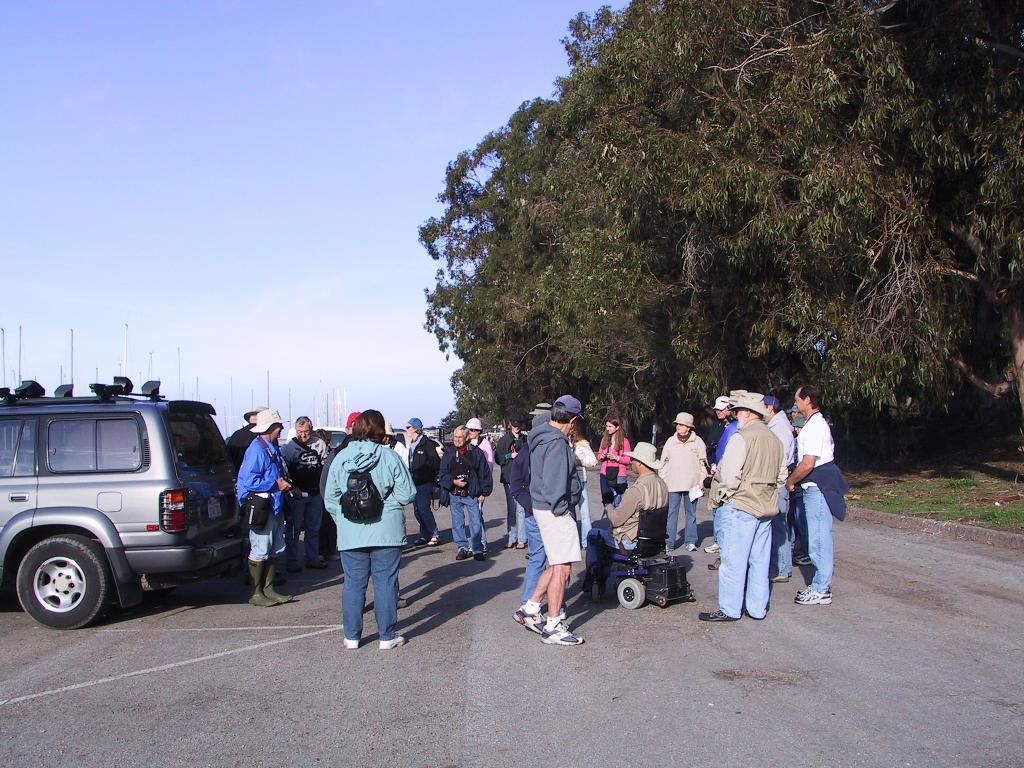Please provide a concise description of this image. There are many people standing. Some are wearing caps and bags. And a person is sitting on a wheelchair. On the right side there are trees. On the left side there is a vehicle. In the background there is sky. 